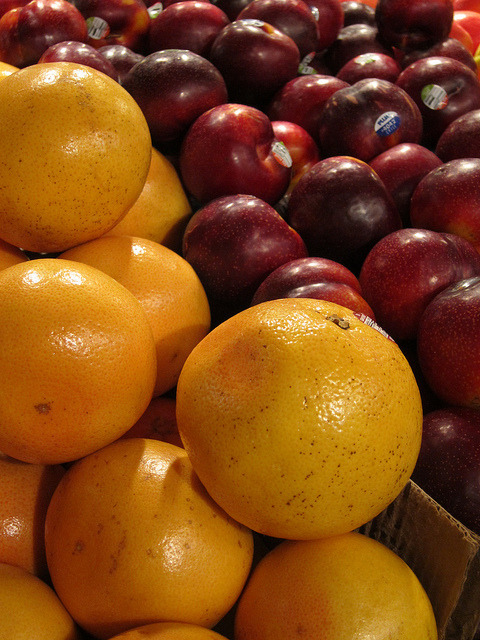Could you make a pie out of the fruits on the left? While it's technically possible to create a pie with oranges, it's not traditional. Orange pies are less common; oranges are better suited for marmalades or as a fresh complement to other dishes. 